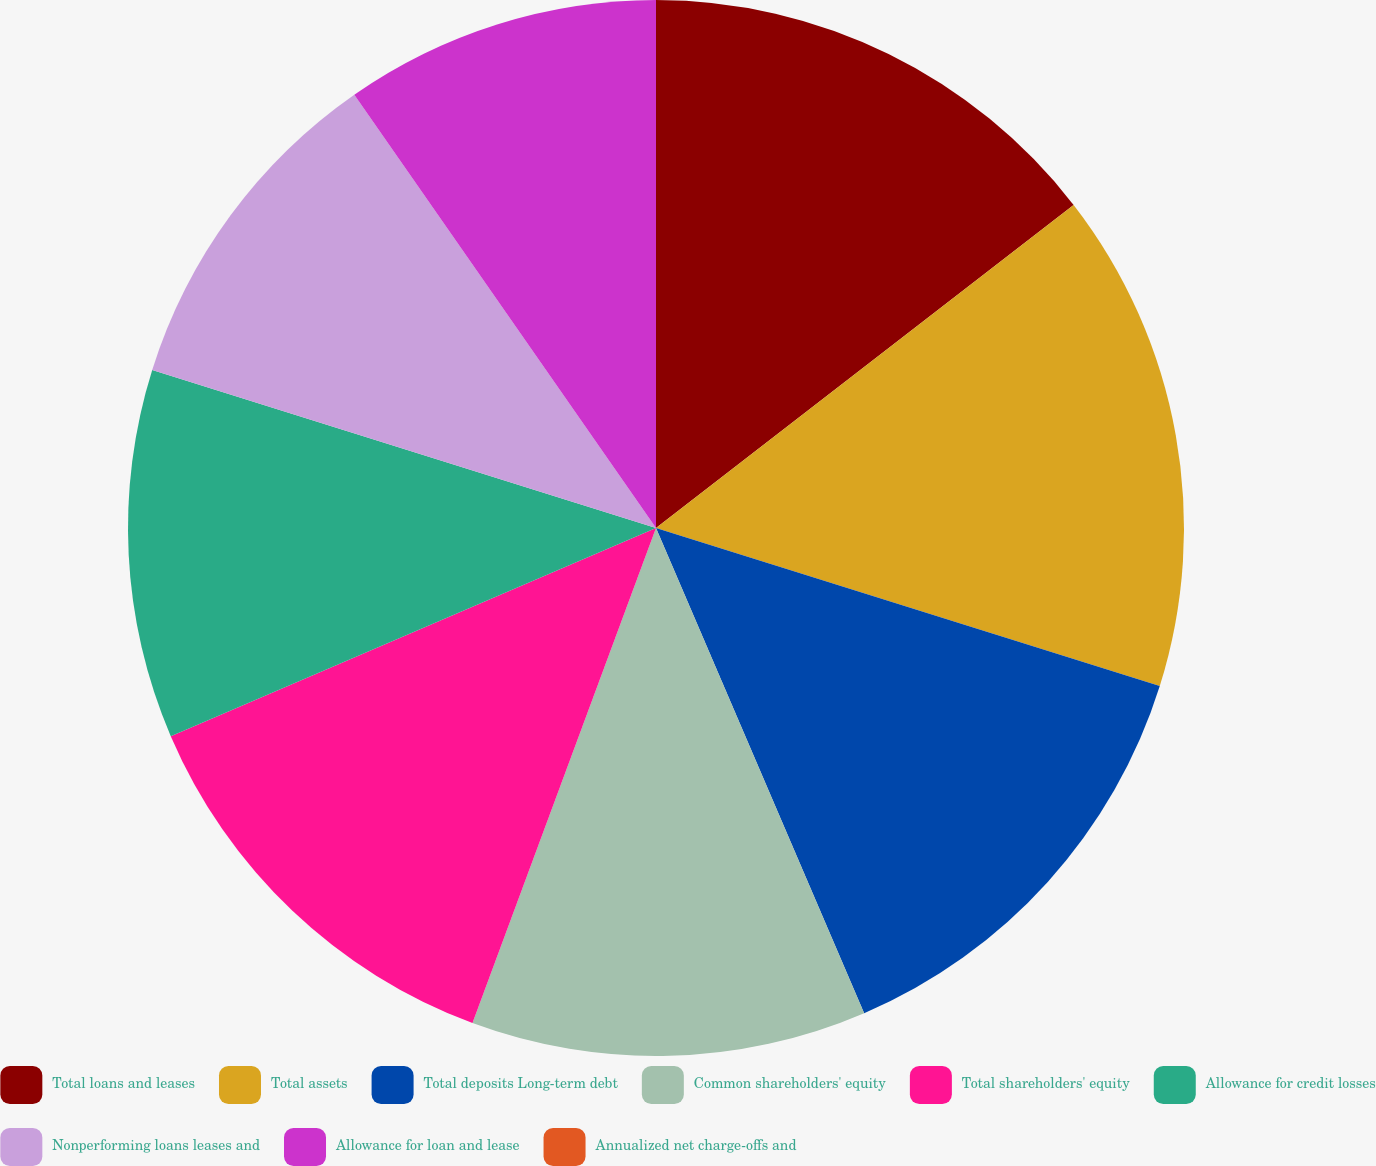<chart> <loc_0><loc_0><loc_500><loc_500><pie_chart><fcel>Total loans and leases<fcel>Total assets<fcel>Total deposits Long-term debt<fcel>Common shareholders' equity<fcel>Total shareholders' equity<fcel>Allowance for credit losses<fcel>Nonperforming loans leases and<fcel>Allowance for loan and lease<fcel>Annualized net charge-offs and<nl><fcel>14.52%<fcel>15.32%<fcel>13.71%<fcel>12.1%<fcel>12.9%<fcel>11.29%<fcel>10.48%<fcel>9.68%<fcel>0.0%<nl></chart> 